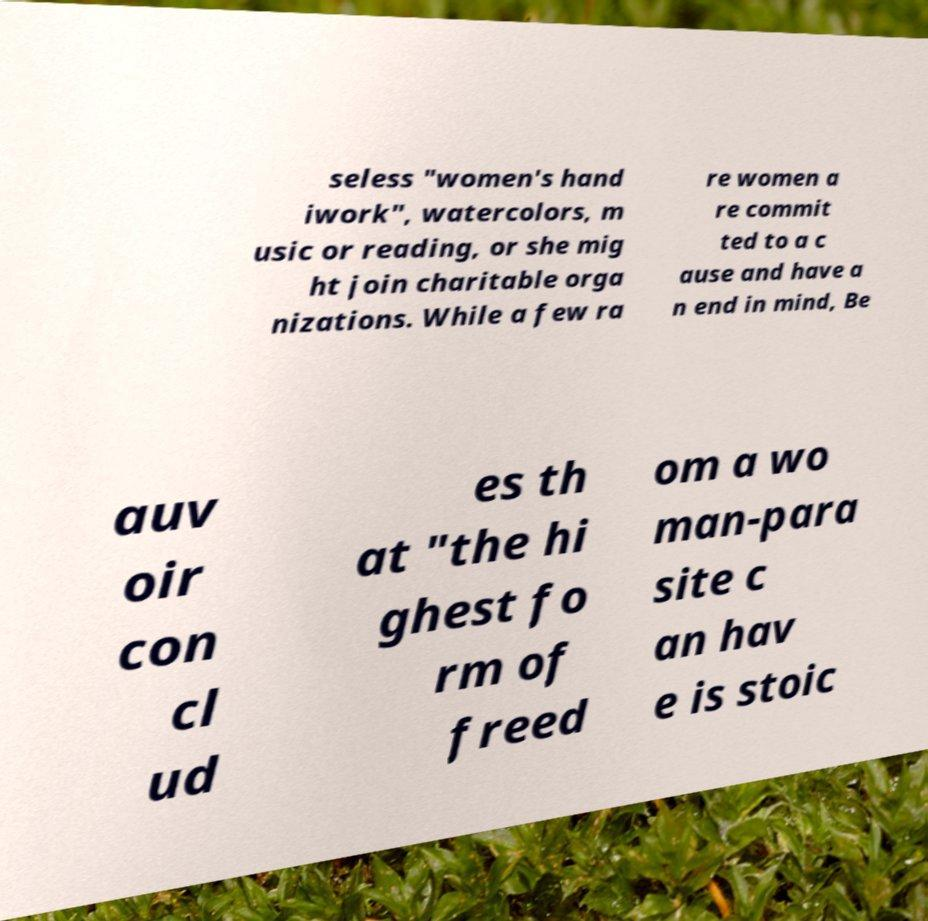Can you accurately transcribe the text from the provided image for me? seless "women's hand iwork", watercolors, m usic or reading, or she mig ht join charitable orga nizations. While a few ra re women a re commit ted to a c ause and have a n end in mind, Be auv oir con cl ud es th at "the hi ghest fo rm of freed om a wo man-para site c an hav e is stoic 